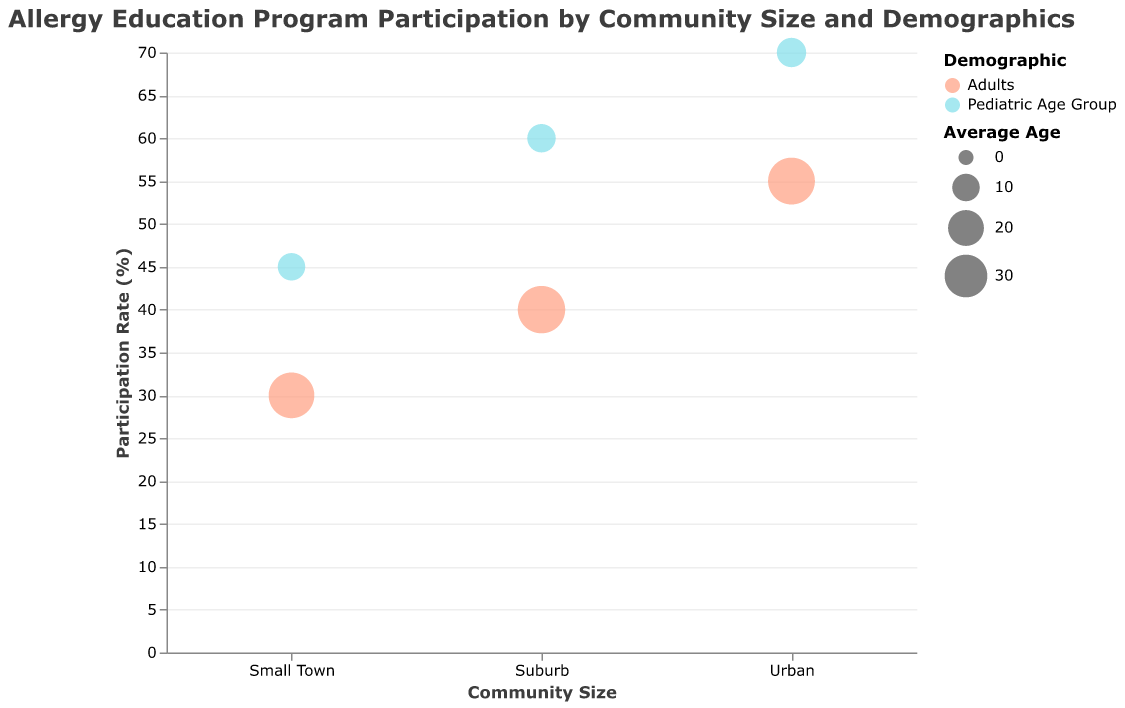Which community size has the highest participation rate for the pediatric age group? The highest participation rate for the pediatric age group can be visually identified by looking at the position of the circles representing pediatric age groups across different community sizes on the y-axis. The urban area has the highest circle for the pediatric age group.
Answer: Urban What is the difference in participation rates between adults in urban areas and adults in small towns? To find this difference, locate the participation rates for adults in both community sizes: 55% for urban adults and 30% for small town adults. The difference is 55 - 30.
Answer: 25 Which demographic group in suburbs has a higher participation rate and what is the participation rate? By comparing the circles in the suburb section, the pediatric age group has a higher participation rate than adults. The participation rate for the pediatric age group in suburbs is shown on the y-axis.
Answer: Pediatric Age Group, 60% What is the unique feature of the pediatric age group circles compared to the adults' circles in terms of size? The size of the circles represents average age. Pediatric age group circles are smaller compared to adults' circles because the average age for the pediatric group is lower.
Answer: Smaller Which community size has the least gender balance in the pediatric age group as indicated by percent females? The percent females can be identified from the tooltip information, which says Small Town has the lowest percent females for the pediatric age group (42%).
Answer: Small Town What is the combined participation rate of all demographic groups in small towns? Add the participation rates of pediatric age group and adults in small towns: 45 + 30 = 75.
Answer: 75 How does the participation rate of pediatric age groups compare between suburban and rural areas? Comparing the y-axis positions, the suburban pediatric age group's participation rate (60%) is less than the urban pediatric age group's (70%).
Answer: Less What is the average participation rate for adults across all community sizes? Add the participation rates for adults in all community sizes and divide by the total numbers: (30 + 40 + 55) / 3. The calculation is 125 / 3.
Answer: Approximately 41.67 Which group has the highest average age and what is that age? The circle sizes indicate the average age. The largest circles correspond to the adult demographic. By checking the tooltip, adults in small towns have the highest average age of 35.
Answer: Adults, 35 